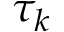<formula> <loc_0><loc_0><loc_500><loc_500>\tau _ { k }</formula> 